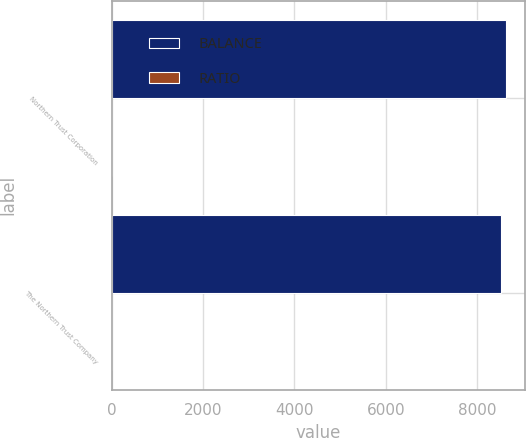Convert chart. <chart><loc_0><loc_0><loc_500><loc_500><stacked_bar_chart><ecel><fcel>Northern Trust Corporation<fcel>The Northern Trust Company<nl><fcel>BALANCE<fcel>8626.3<fcel>8517.8<nl><fcel>RATIO<fcel>13.5<fcel>13.7<nl></chart> 